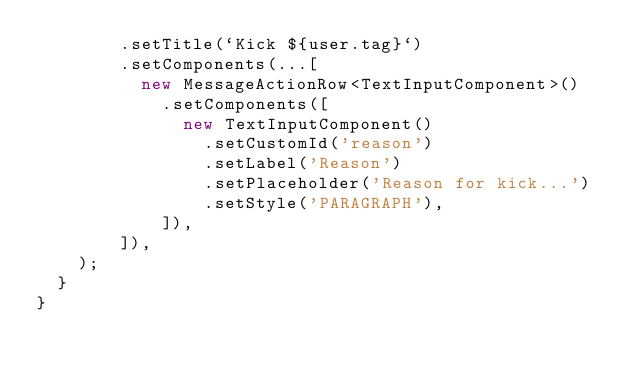Convert code to text. <code><loc_0><loc_0><loc_500><loc_500><_TypeScript_>        .setTitle(`Kick ${user.tag}`)
        .setComponents(...[
          new MessageActionRow<TextInputComponent>()
            .setComponents([
              new TextInputComponent()
                .setCustomId('reason')
                .setLabel('Reason')
                .setPlaceholder('Reason for kick...')
                .setStyle('PARAGRAPH'),
            ]),
        ]),
    );
  }
}</code> 